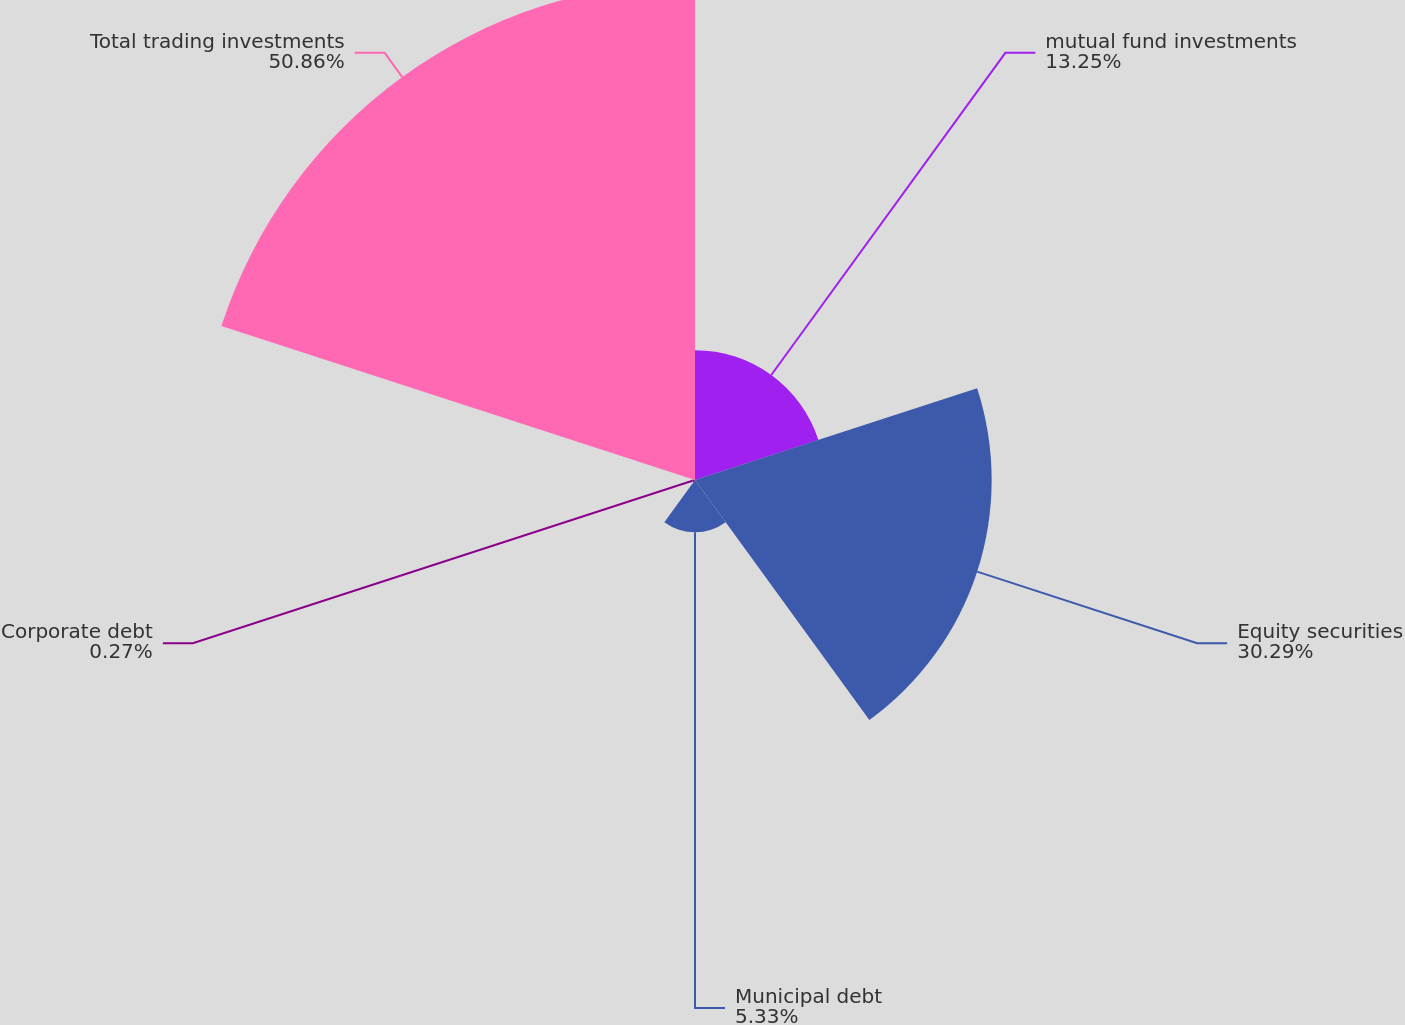Convert chart to OTSL. <chart><loc_0><loc_0><loc_500><loc_500><pie_chart><fcel>mutual fund investments<fcel>Equity securities<fcel>Municipal debt<fcel>Corporate debt<fcel>Total trading investments<nl><fcel>13.25%<fcel>30.29%<fcel>5.33%<fcel>0.27%<fcel>50.85%<nl></chart> 